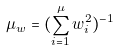Convert formula to latex. <formula><loc_0><loc_0><loc_500><loc_500>\mu _ { w } = ( \sum _ { i = 1 } ^ { \mu } w _ { i } ^ { 2 } ) ^ { - 1 }</formula> 